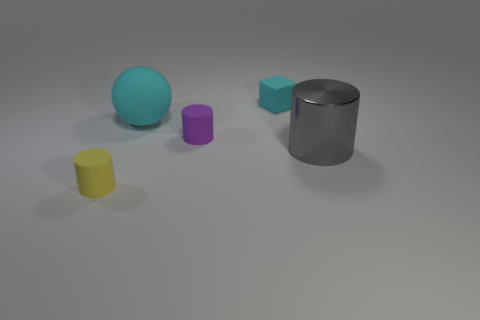Subtract all tiny matte cylinders. How many cylinders are left? 1 Subtract 1 cylinders. How many cylinders are left? 2 Add 1 large matte balls. How many objects exist? 6 Subtract all brown cylinders. Subtract all cyan spheres. How many cylinders are left? 3 Subtract all balls. How many objects are left? 4 Subtract 0 blue cylinders. How many objects are left? 5 Subtract all small cyan matte blocks. Subtract all rubber cylinders. How many objects are left? 2 Add 1 tiny purple objects. How many tiny purple objects are left? 2 Add 4 gray things. How many gray things exist? 5 